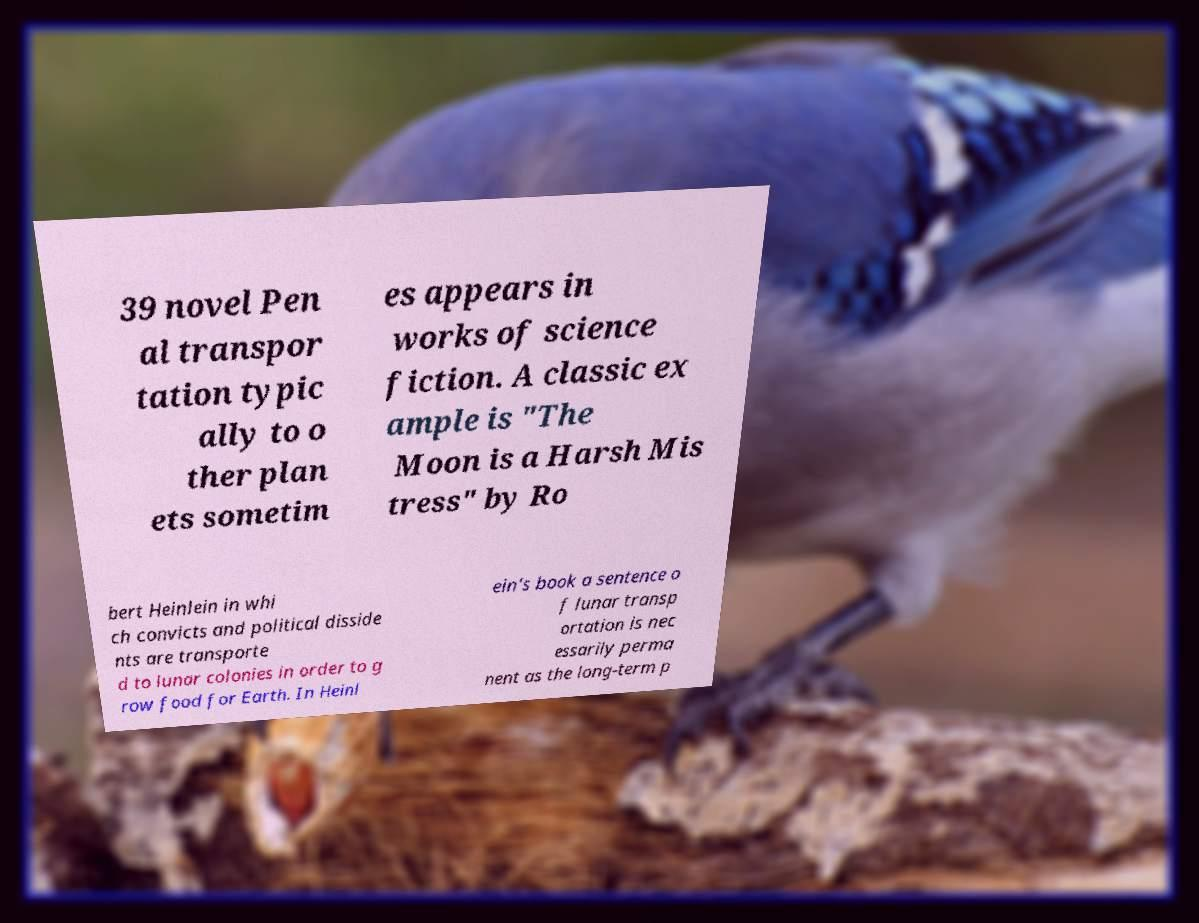For documentation purposes, I need the text within this image transcribed. Could you provide that? 39 novel Pen al transpor tation typic ally to o ther plan ets sometim es appears in works of science fiction. A classic ex ample is "The Moon is a Harsh Mis tress" by Ro bert Heinlein in whi ch convicts and political disside nts are transporte d to lunar colonies in order to g row food for Earth. In Heinl ein's book a sentence o f lunar transp ortation is nec essarily perma nent as the long-term p 